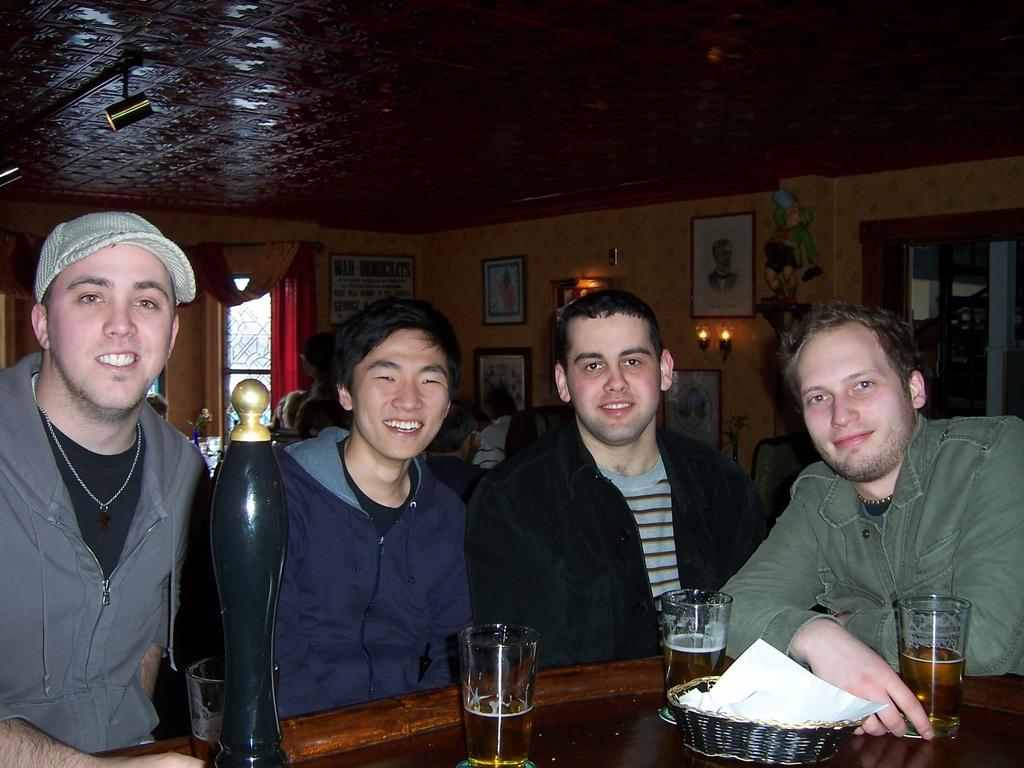How many people are in the image? There are four men in the image. What are the men doing in the image? The men are laughing. What can be seen on the table in front of the men? There are glasses of beer on a table in front of the men. What type of crops is the farmer harvesting in the image? There is no farmer or crops present in the image; it features four men laughing with glasses of beer on a table. 